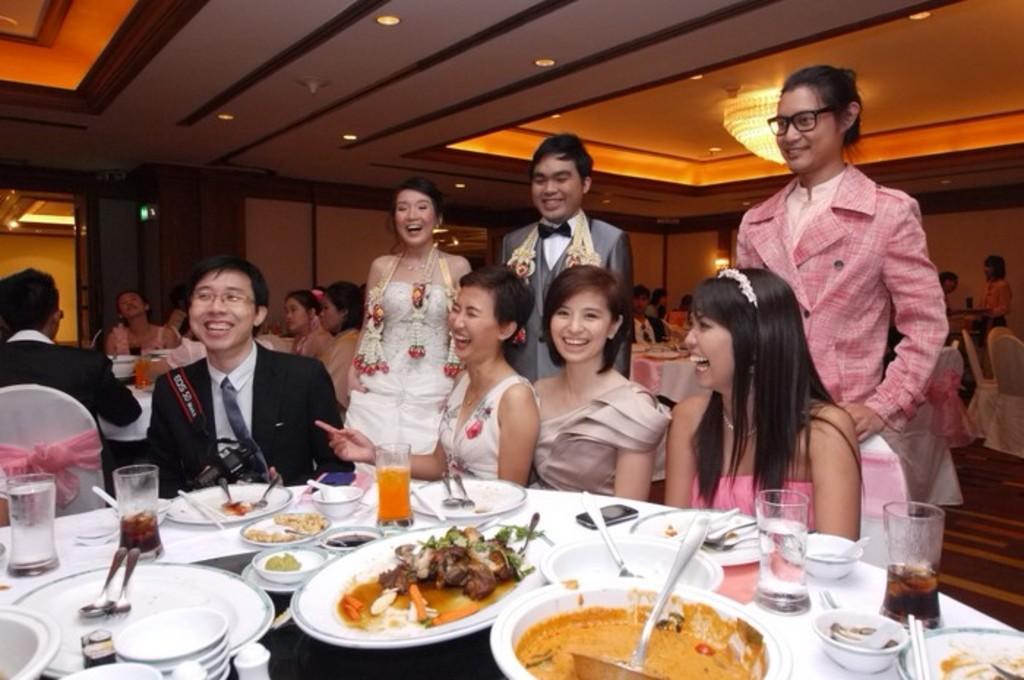Could you give a brief overview of what you see in this image? As we can see in the image there are few people here and there, wall, lights, chandelier, chairs and tables. On table there are plates, bowls, glasses and different types of dishes. 